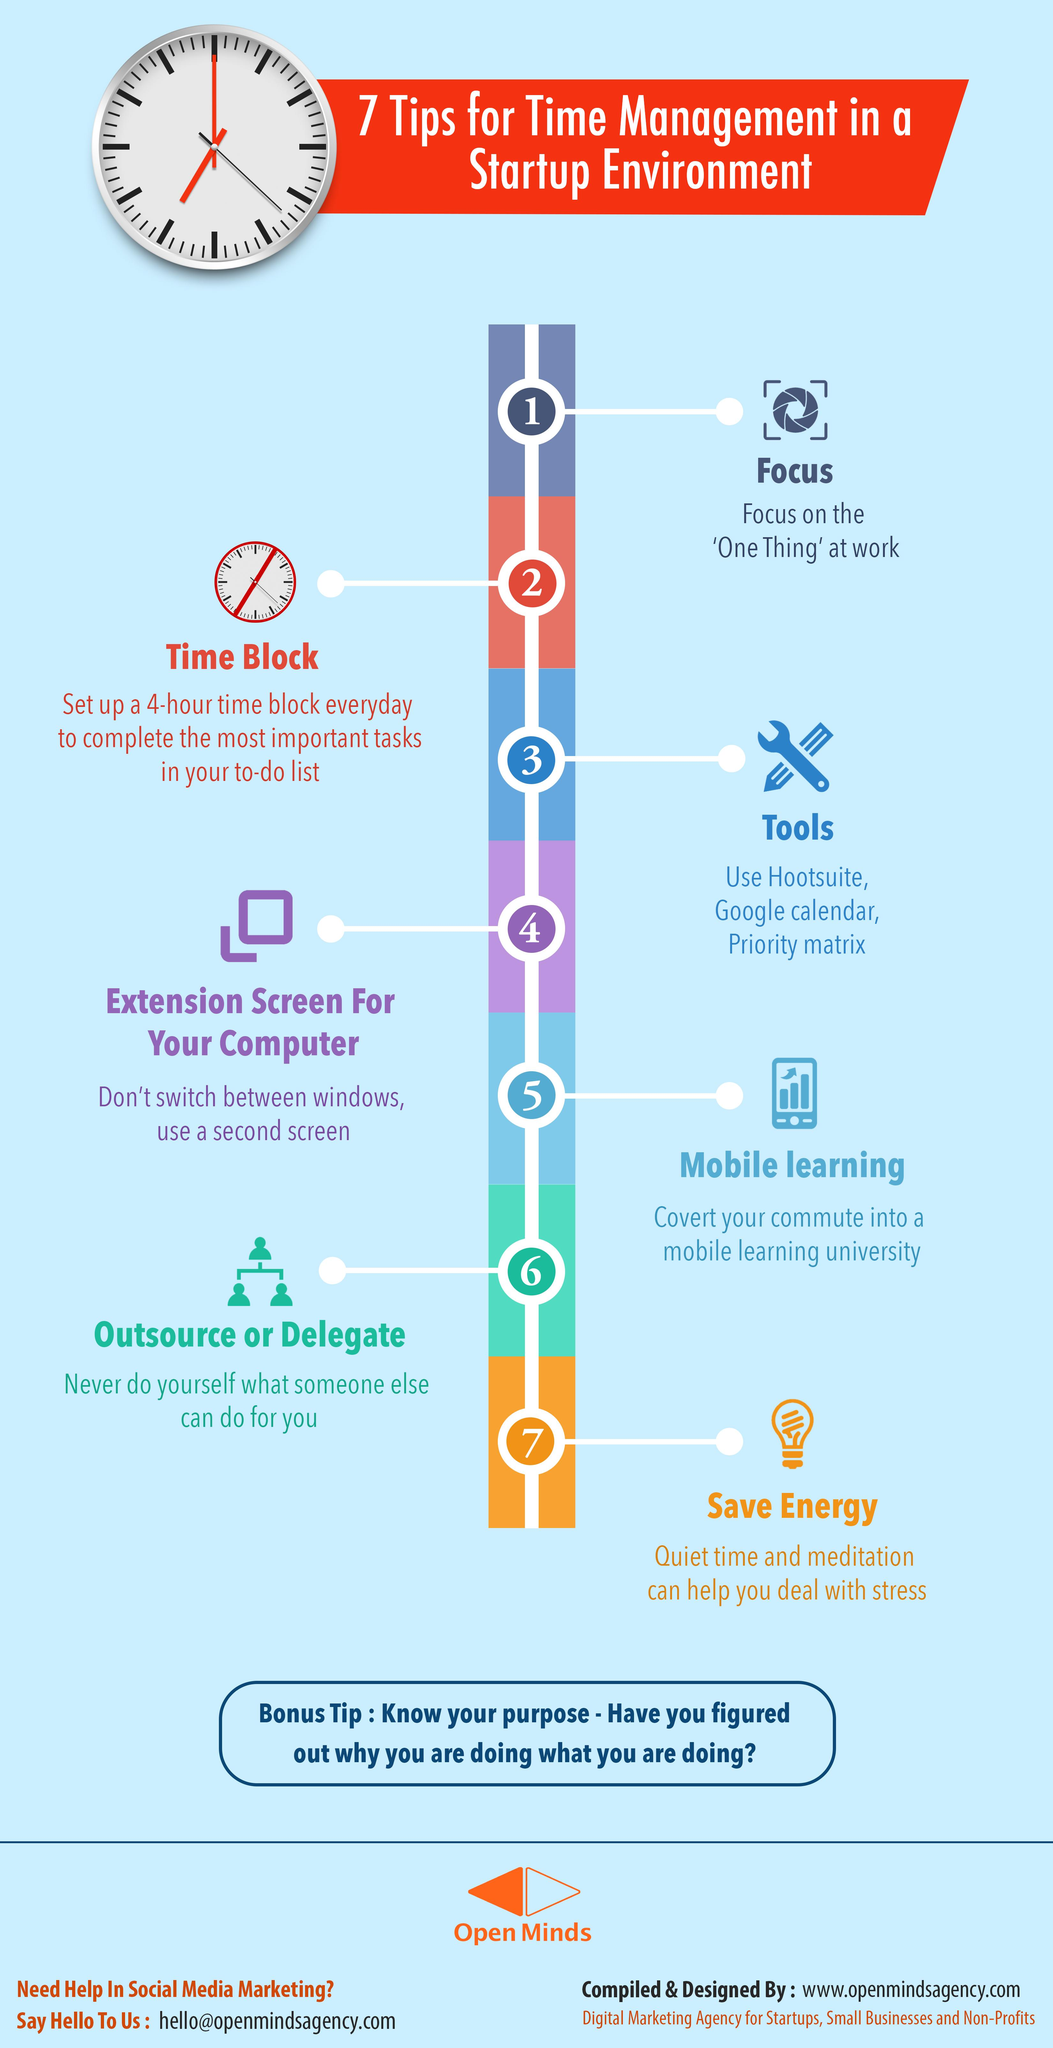Point out several critical features in this image. The tip number corresponding to the suggestion to use a second screen is 4. The last tip written on the left side of the image is 'Outsource or delegate.' There are three tips mentioned to the left of the image. It is recommended to complete tasks in a to-do list starting from the second tip. Priority matrix is the third tool in the list of tools that aid in time management, which helps in effectively managing time. 